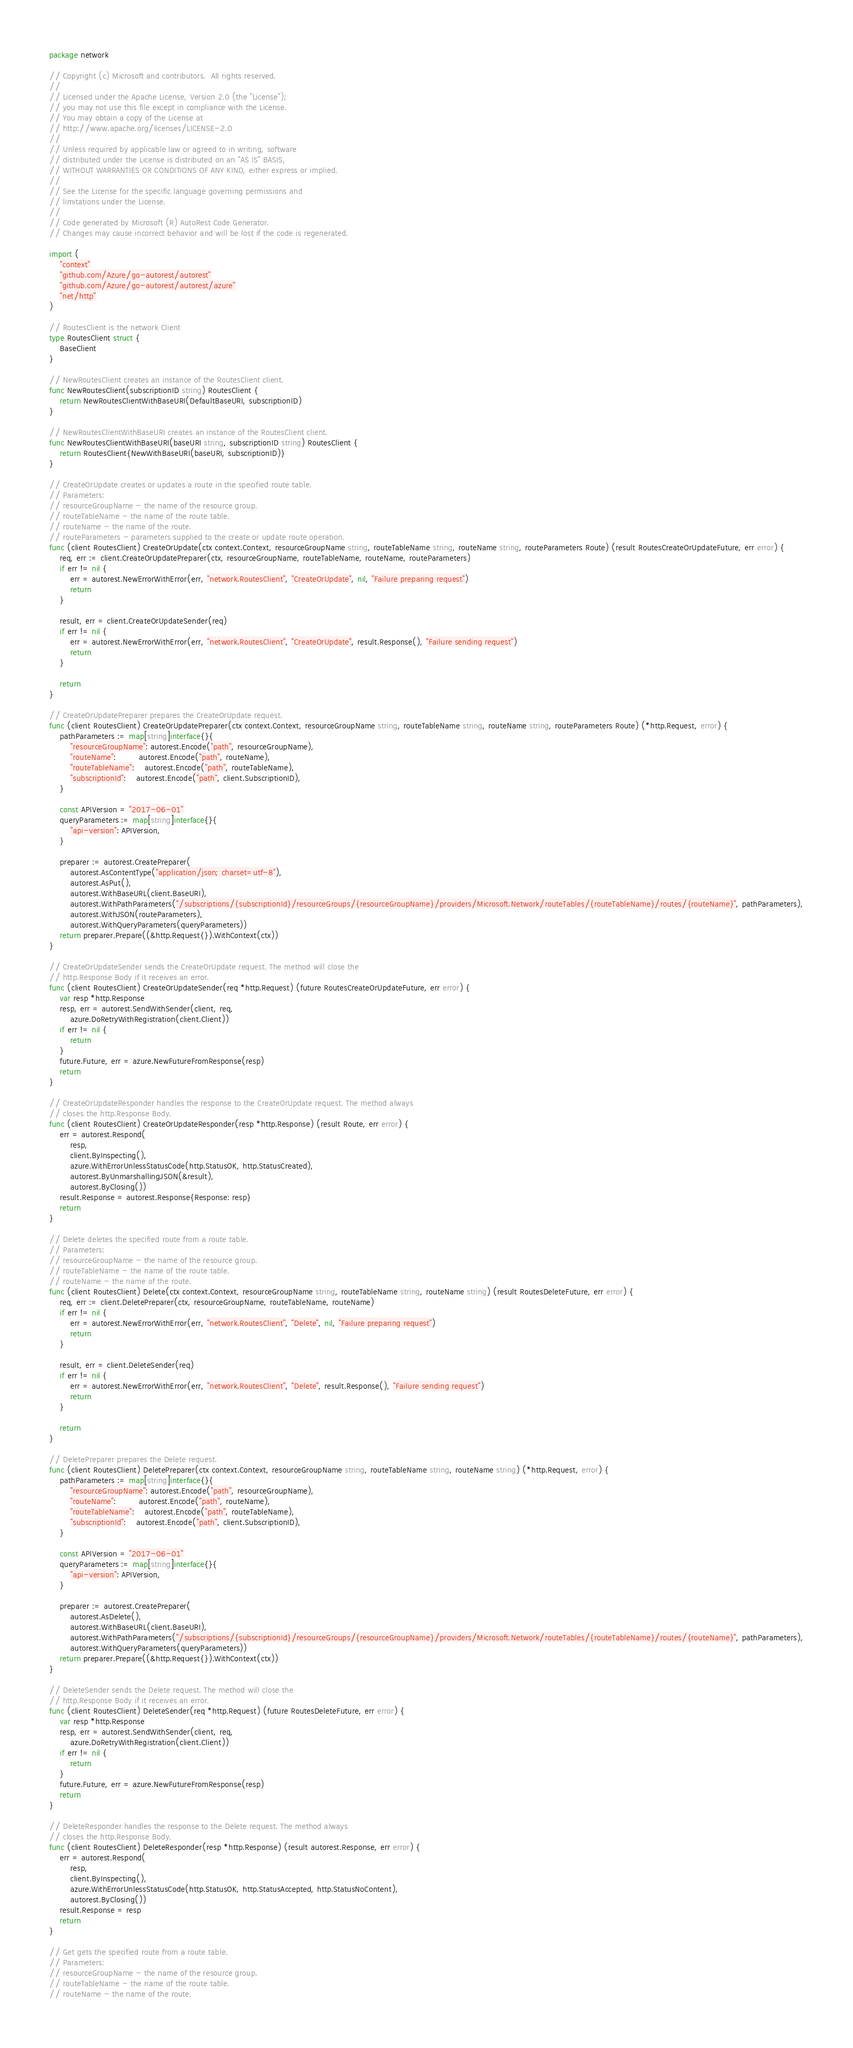Convert code to text. <code><loc_0><loc_0><loc_500><loc_500><_Go_>package network

// Copyright (c) Microsoft and contributors.  All rights reserved.
//
// Licensed under the Apache License, Version 2.0 (the "License");
// you may not use this file except in compliance with the License.
// You may obtain a copy of the License at
// http://www.apache.org/licenses/LICENSE-2.0
//
// Unless required by applicable law or agreed to in writing, software
// distributed under the License is distributed on an "AS IS" BASIS,
// WITHOUT WARRANTIES OR CONDITIONS OF ANY KIND, either express or implied.
//
// See the License for the specific language governing permissions and
// limitations under the License.
//
// Code generated by Microsoft (R) AutoRest Code Generator.
// Changes may cause incorrect behavior and will be lost if the code is regenerated.

import (
	"context"
	"github.com/Azure/go-autorest/autorest"
	"github.com/Azure/go-autorest/autorest/azure"
	"net/http"
)

// RoutesClient is the network Client
type RoutesClient struct {
	BaseClient
}

// NewRoutesClient creates an instance of the RoutesClient client.
func NewRoutesClient(subscriptionID string) RoutesClient {
	return NewRoutesClientWithBaseURI(DefaultBaseURI, subscriptionID)
}

// NewRoutesClientWithBaseURI creates an instance of the RoutesClient client.
func NewRoutesClientWithBaseURI(baseURI string, subscriptionID string) RoutesClient {
	return RoutesClient{NewWithBaseURI(baseURI, subscriptionID)}
}

// CreateOrUpdate creates or updates a route in the specified route table.
// Parameters:
// resourceGroupName - the name of the resource group.
// routeTableName - the name of the route table.
// routeName - the name of the route.
// routeParameters - parameters supplied to the create or update route operation.
func (client RoutesClient) CreateOrUpdate(ctx context.Context, resourceGroupName string, routeTableName string, routeName string, routeParameters Route) (result RoutesCreateOrUpdateFuture, err error) {
	req, err := client.CreateOrUpdatePreparer(ctx, resourceGroupName, routeTableName, routeName, routeParameters)
	if err != nil {
		err = autorest.NewErrorWithError(err, "network.RoutesClient", "CreateOrUpdate", nil, "Failure preparing request")
		return
	}

	result, err = client.CreateOrUpdateSender(req)
	if err != nil {
		err = autorest.NewErrorWithError(err, "network.RoutesClient", "CreateOrUpdate", result.Response(), "Failure sending request")
		return
	}

	return
}

// CreateOrUpdatePreparer prepares the CreateOrUpdate request.
func (client RoutesClient) CreateOrUpdatePreparer(ctx context.Context, resourceGroupName string, routeTableName string, routeName string, routeParameters Route) (*http.Request, error) {
	pathParameters := map[string]interface{}{
		"resourceGroupName": autorest.Encode("path", resourceGroupName),
		"routeName":         autorest.Encode("path", routeName),
		"routeTableName":    autorest.Encode("path", routeTableName),
		"subscriptionId":    autorest.Encode("path", client.SubscriptionID),
	}

	const APIVersion = "2017-06-01"
	queryParameters := map[string]interface{}{
		"api-version": APIVersion,
	}

	preparer := autorest.CreatePreparer(
		autorest.AsContentType("application/json; charset=utf-8"),
		autorest.AsPut(),
		autorest.WithBaseURL(client.BaseURI),
		autorest.WithPathParameters("/subscriptions/{subscriptionId}/resourceGroups/{resourceGroupName}/providers/Microsoft.Network/routeTables/{routeTableName}/routes/{routeName}", pathParameters),
		autorest.WithJSON(routeParameters),
		autorest.WithQueryParameters(queryParameters))
	return preparer.Prepare((&http.Request{}).WithContext(ctx))
}

// CreateOrUpdateSender sends the CreateOrUpdate request. The method will close the
// http.Response Body if it receives an error.
func (client RoutesClient) CreateOrUpdateSender(req *http.Request) (future RoutesCreateOrUpdateFuture, err error) {
	var resp *http.Response
	resp, err = autorest.SendWithSender(client, req,
		azure.DoRetryWithRegistration(client.Client))
	if err != nil {
		return
	}
	future.Future, err = azure.NewFutureFromResponse(resp)
	return
}

// CreateOrUpdateResponder handles the response to the CreateOrUpdate request. The method always
// closes the http.Response Body.
func (client RoutesClient) CreateOrUpdateResponder(resp *http.Response) (result Route, err error) {
	err = autorest.Respond(
		resp,
		client.ByInspecting(),
		azure.WithErrorUnlessStatusCode(http.StatusOK, http.StatusCreated),
		autorest.ByUnmarshallingJSON(&result),
		autorest.ByClosing())
	result.Response = autorest.Response{Response: resp}
	return
}

// Delete deletes the specified route from a route table.
// Parameters:
// resourceGroupName - the name of the resource group.
// routeTableName - the name of the route table.
// routeName - the name of the route.
func (client RoutesClient) Delete(ctx context.Context, resourceGroupName string, routeTableName string, routeName string) (result RoutesDeleteFuture, err error) {
	req, err := client.DeletePreparer(ctx, resourceGroupName, routeTableName, routeName)
	if err != nil {
		err = autorest.NewErrorWithError(err, "network.RoutesClient", "Delete", nil, "Failure preparing request")
		return
	}

	result, err = client.DeleteSender(req)
	if err != nil {
		err = autorest.NewErrorWithError(err, "network.RoutesClient", "Delete", result.Response(), "Failure sending request")
		return
	}

	return
}

// DeletePreparer prepares the Delete request.
func (client RoutesClient) DeletePreparer(ctx context.Context, resourceGroupName string, routeTableName string, routeName string) (*http.Request, error) {
	pathParameters := map[string]interface{}{
		"resourceGroupName": autorest.Encode("path", resourceGroupName),
		"routeName":         autorest.Encode("path", routeName),
		"routeTableName":    autorest.Encode("path", routeTableName),
		"subscriptionId":    autorest.Encode("path", client.SubscriptionID),
	}

	const APIVersion = "2017-06-01"
	queryParameters := map[string]interface{}{
		"api-version": APIVersion,
	}

	preparer := autorest.CreatePreparer(
		autorest.AsDelete(),
		autorest.WithBaseURL(client.BaseURI),
		autorest.WithPathParameters("/subscriptions/{subscriptionId}/resourceGroups/{resourceGroupName}/providers/Microsoft.Network/routeTables/{routeTableName}/routes/{routeName}", pathParameters),
		autorest.WithQueryParameters(queryParameters))
	return preparer.Prepare((&http.Request{}).WithContext(ctx))
}

// DeleteSender sends the Delete request. The method will close the
// http.Response Body if it receives an error.
func (client RoutesClient) DeleteSender(req *http.Request) (future RoutesDeleteFuture, err error) {
	var resp *http.Response
	resp, err = autorest.SendWithSender(client, req,
		azure.DoRetryWithRegistration(client.Client))
	if err != nil {
		return
	}
	future.Future, err = azure.NewFutureFromResponse(resp)
	return
}

// DeleteResponder handles the response to the Delete request. The method always
// closes the http.Response Body.
func (client RoutesClient) DeleteResponder(resp *http.Response) (result autorest.Response, err error) {
	err = autorest.Respond(
		resp,
		client.ByInspecting(),
		azure.WithErrorUnlessStatusCode(http.StatusOK, http.StatusAccepted, http.StatusNoContent),
		autorest.ByClosing())
	result.Response = resp
	return
}

// Get gets the specified route from a route table.
// Parameters:
// resourceGroupName - the name of the resource group.
// routeTableName - the name of the route table.
// routeName - the name of the route.</code> 